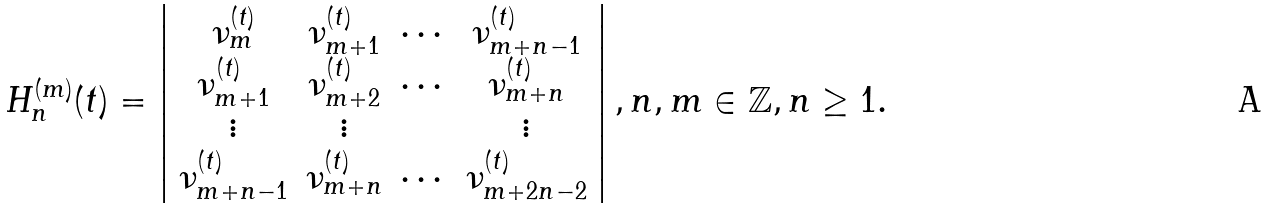<formula> <loc_0><loc_0><loc_500><loc_500>H _ { n } ^ { ( m ) } ( t ) = \left | \begin{array} { c c c c } \nu _ { m } ^ { ( t ) } & \nu _ { m + 1 } ^ { ( t ) } & \cdots & \nu _ { m + n - 1 } ^ { ( t ) } \\ \nu _ { m + 1 } ^ { ( t ) } & \nu _ { m + 2 } ^ { ( t ) } & \cdots & \nu _ { m + n } ^ { ( t ) } \\ \vdots & \vdots & & \vdots \\ \nu _ { m + n - 1 } ^ { ( t ) } & \nu _ { m + n } ^ { ( t ) } & \cdots & \nu _ { m + 2 n - 2 } ^ { ( t ) } \\ \end{array} \right | , n , m \in \mathbb { Z } , n \geq 1 .</formula> 